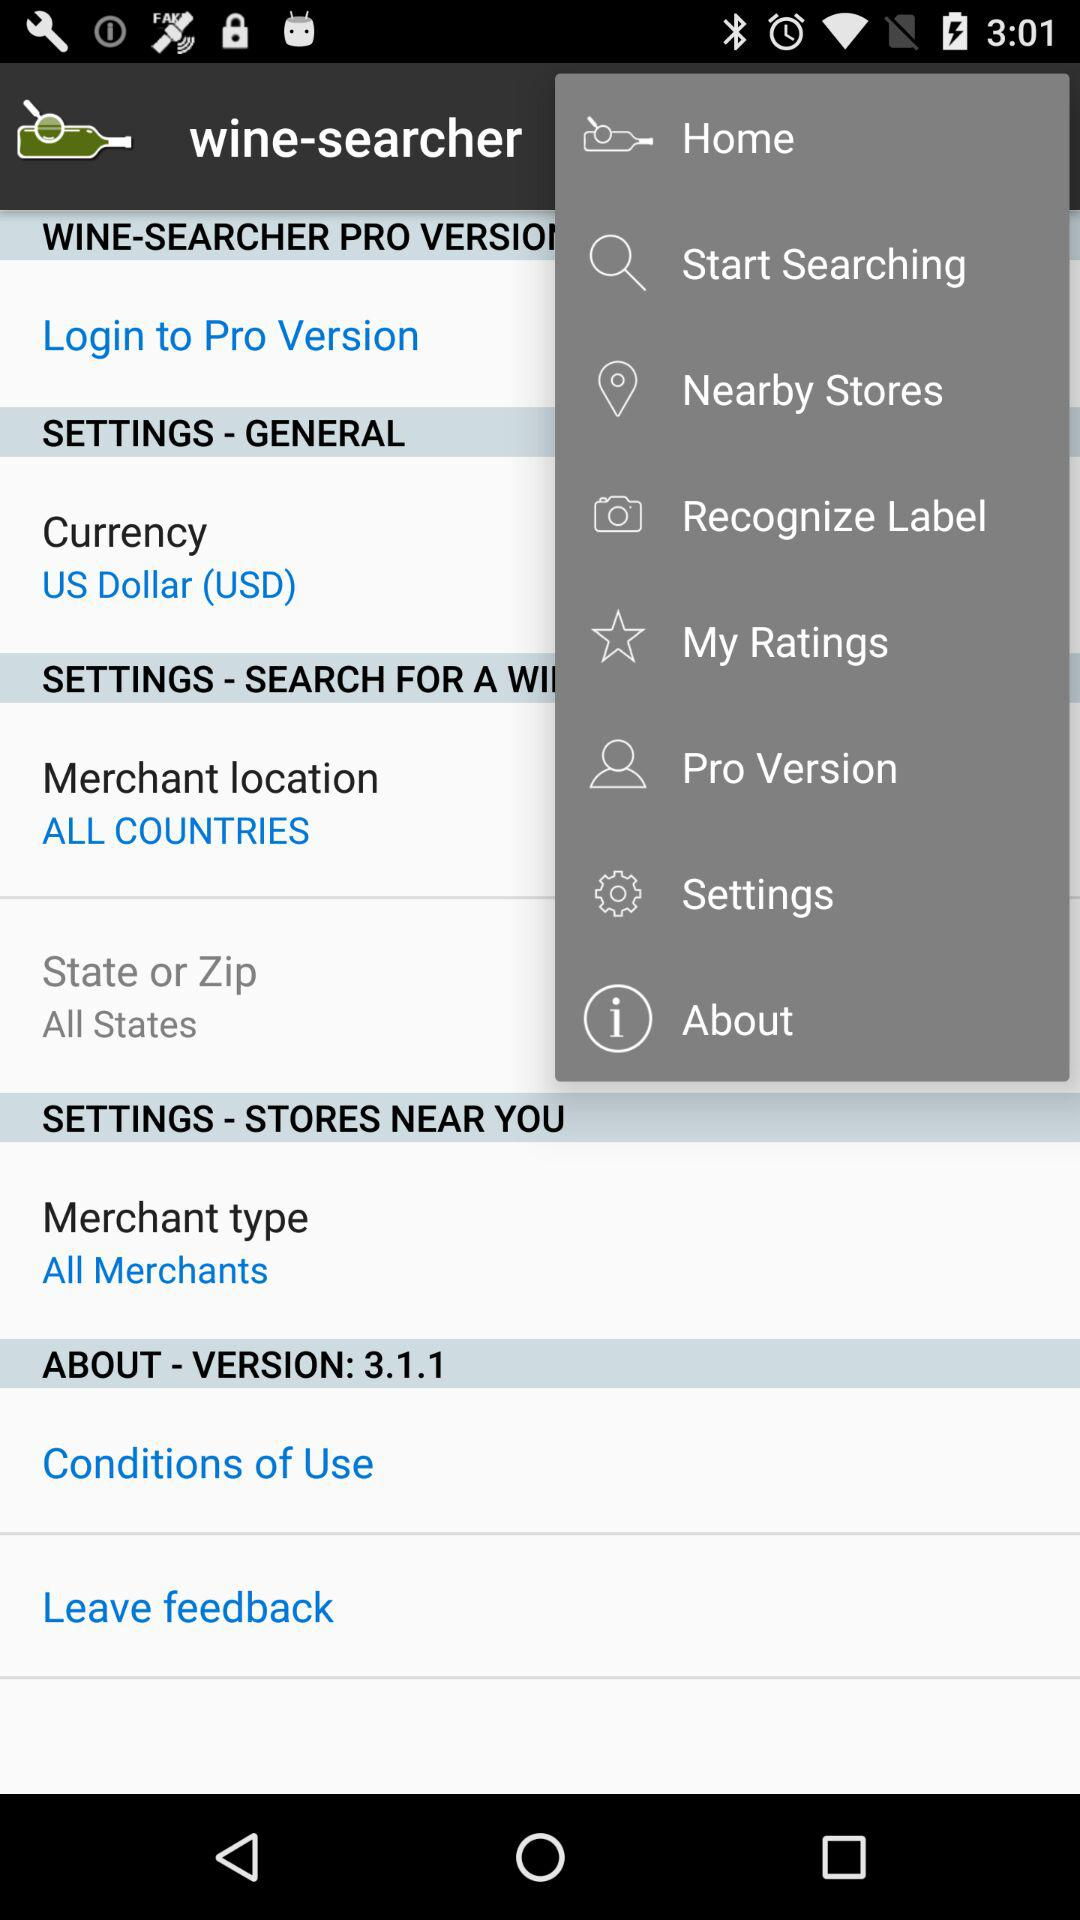What is the currency? The currency is the US Dollar (USD). 